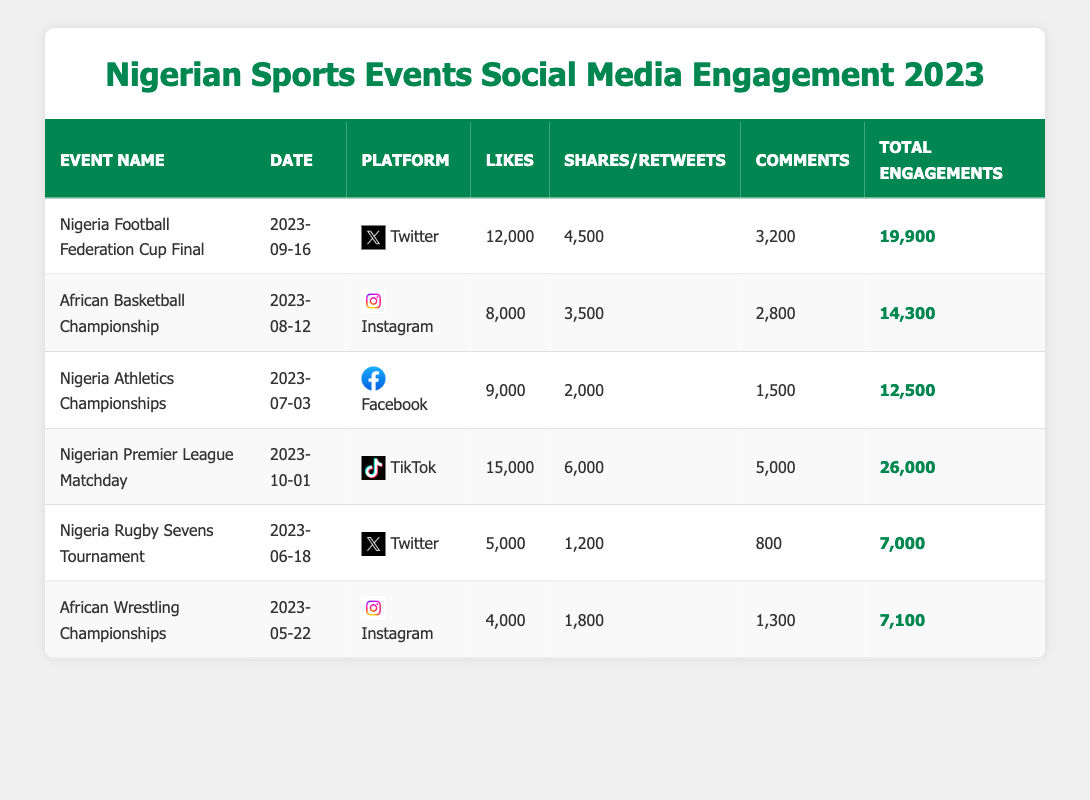What was the total engagement for the Nigeria Football Federation Cup Final? The table shows that the total engagements for the Nigeria Football Federation Cup Final are listed as 19,900.
Answer: 19,900 Which event had the highest number of likes, and how many did it receive? By reviewing the Likes column, we see that the Nigerian Premier League Matchday had the highest likes at 15,000.
Answer: Nigerian Premier League Matchday, 15,000 Did the Nigeria Rugby Sevens Tournament have more shares/retweets than the African Wrestling Championships? Comparing the shares/retweets for both events, Nigeria Rugby Sevens Tournament has 1,200 while African Wrestling Championships has 1,800. Since 1,200 is less than 1,800, the statement is false.
Answer: No What is the average total engagement across all six events listed? The total engagements are 19,900, 14,300, 12,500, 26,000, 7,000, and 7,100. Adding these gives 86,800, and dividing by the number of events (6) results in 14,467.
Answer: 14,467 Was the engagement on TikTok for the Nigerian Premier League Matchday the highest compared to all other platforms? The TikTok engagement for the Nigerian Premier League Matchday is 26,000. Comparing this with the total engagements on other platforms: 19,900 (Twitter), 14,300 (Instagram), 12,500 (Facebook), 7,000 (Twitter), and 7,100 (Instagram) confirms that 26,000 is indeed the highest.
Answer: Yes How many more comments did the African Basketball Championship receive compared to the Nigeria Rugby Sevens Tournament? The African Basketball Championship received 2,800 comments, while the Nigeria Rugby Sevens Tournament had 800 comments. Finding the difference, 2,800 - 800 equals 2,000.
Answer: 2,000 